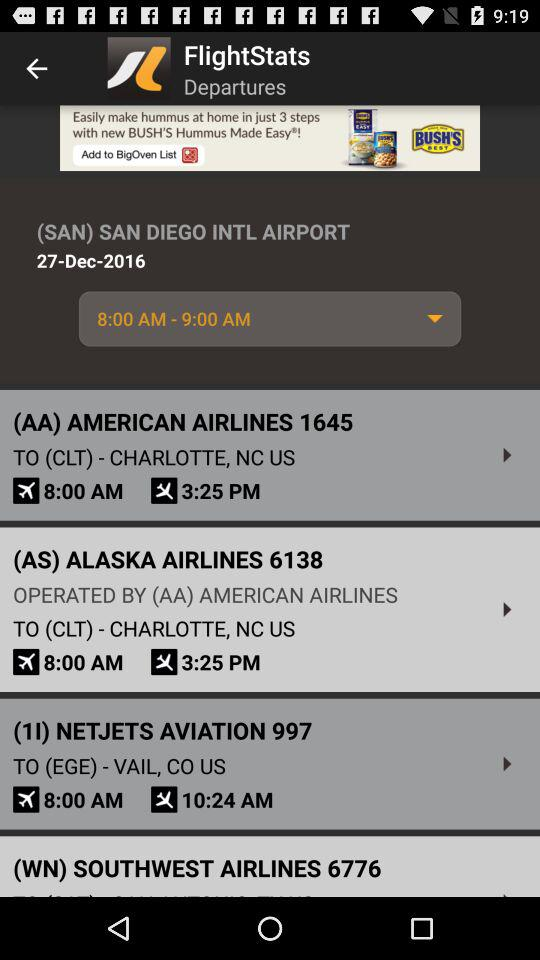What is the flight departure time from CLT?
When the provided information is insufficient, respond with <no answer>. <no answer> 